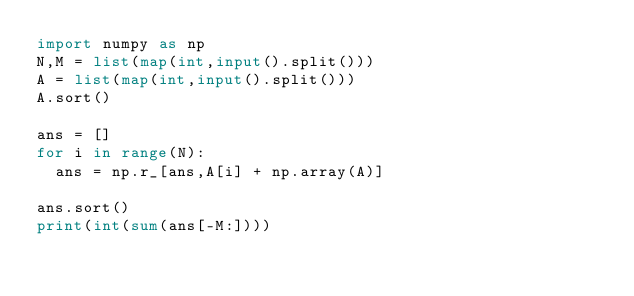Convert code to text. <code><loc_0><loc_0><loc_500><loc_500><_Python_>import numpy as np
N,M = list(map(int,input().split()))
A = list(map(int,input().split()))
A.sort()
 
ans = []
for i in range(N):
  ans = np.r_[ans,A[i] + np.array(A)]

ans.sort()
print(int(sum(ans[-M:])))
</code> 